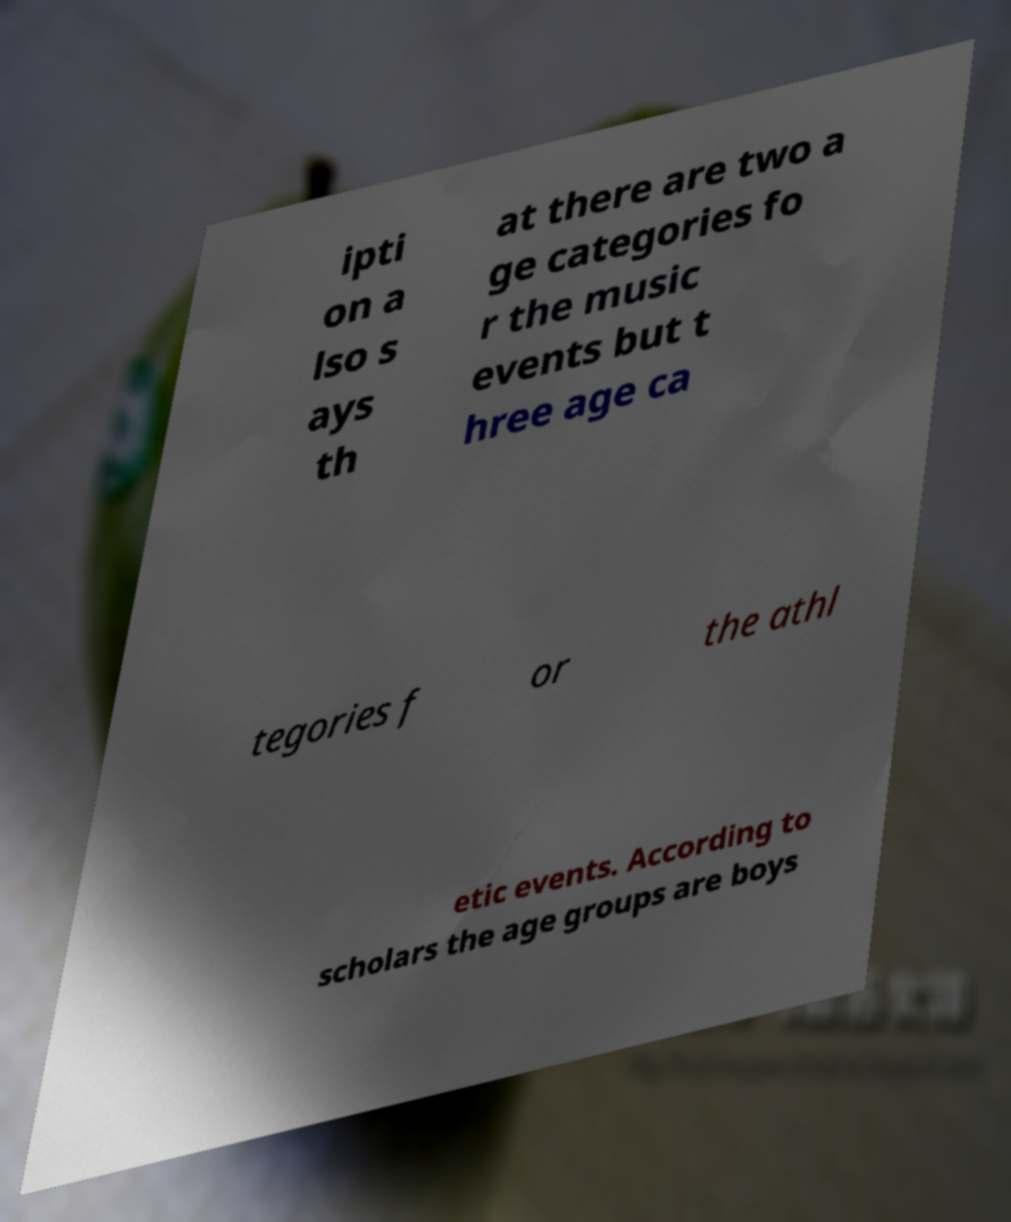I need the written content from this picture converted into text. Can you do that? ipti on a lso s ays th at there are two a ge categories fo r the music events but t hree age ca tegories f or the athl etic events. According to scholars the age groups are boys 